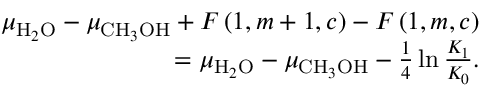Convert formula to latex. <formula><loc_0><loc_0><loc_500><loc_500>\begin{array} { r } { \mu _ { H _ { 2 } O } - \mu _ { C H _ { 3 } O H } + F \left ( 1 , m + 1 , c \right ) - F \left ( 1 , m , c \right ) } \\ { = \mu _ { H _ { 2 } O } - \mu _ { C H _ { 3 } O H } - \frac { 1 } { 4 } \ln \frac { K _ { 1 } } { K _ { 0 } } . } \end{array}</formula> 